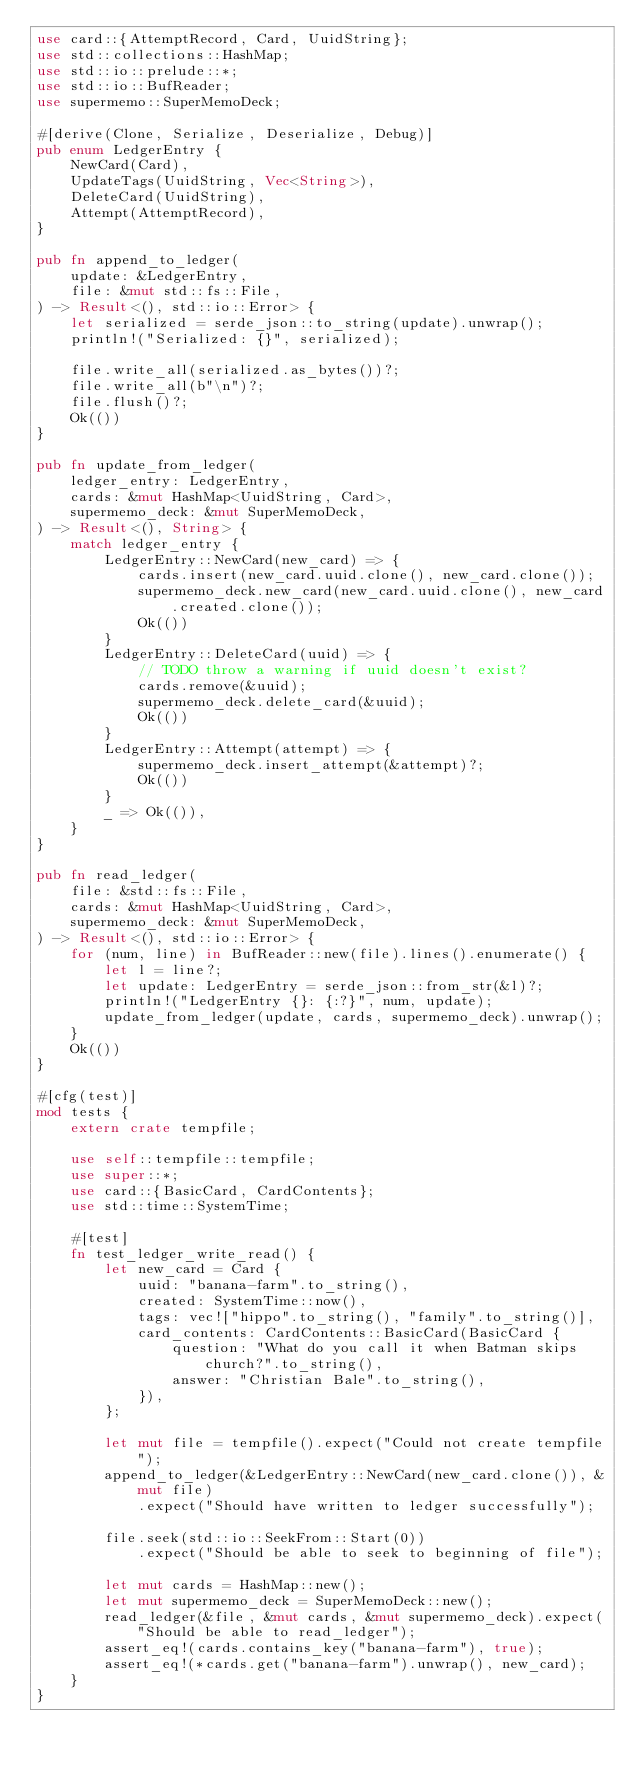<code> <loc_0><loc_0><loc_500><loc_500><_Rust_>use card::{AttemptRecord, Card, UuidString};
use std::collections::HashMap;
use std::io::prelude::*;
use std::io::BufReader;
use supermemo::SuperMemoDeck;

#[derive(Clone, Serialize, Deserialize, Debug)]
pub enum LedgerEntry {
    NewCard(Card),
    UpdateTags(UuidString, Vec<String>),
    DeleteCard(UuidString),
    Attempt(AttemptRecord),
}

pub fn append_to_ledger(
    update: &LedgerEntry,
    file: &mut std::fs::File,
) -> Result<(), std::io::Error> {
    let serialized = serde_json::to_string(update).unwrap();
    println!("Serialized: {}", serialized);

    file.write_all(serialized.as_bytes())?;
    file.write_all(b"\n")?;
    file.flush()?;
    Ok(())
}

pub fn update_from_ledger(
    ledger_entry: LedgerEntry,
    cards: &mut HashMap<UuidString, Card>,
    supermemo_deck: &mut SuperMemoDeck,
) -> Result<(), String> {
    match ledger_entry {
        LedgerEntry::NewCard(new_card) => {
            cards.insert(new_card.uuid.clone(), new_card.clone());
            supermemo_deck.new_card(new_card.uuid.clone(), new_card.created.clone());
            Ok(())
        }
        LedgerEntry::DeleteCard(uuid) => {
            // TODO throw a warning if uuid doesn't exist?
            cards.remove(&uuid);
            supermemo_deck.delete_card(&uuid);
            Ok(())
        }
        LedgerEntry::Attempt(attempt) => {
            supermemo_deck.insert_attempt(&attempt)?;
            Ok(())
        }
        _ => Ok(()),
    }
}

pub fn read_ledger(
    file: &std::fs::File,
    cards: &mut HashMap<UuidString, Card>,
    supermemo_deck: &mut SuperMemoDeck,
) -> Result<(), std::io::Error> {
    for (num, line) in BufReader::new(file).lines().enumerate() {
        let l = line?;
        let update: LedgerEntry = serde_json::from_str(&l)?;
        println!("LedgerEntry {}: {:?}", num, update);
        update_from_ledger(update, cards, supermemo_deck).unwrap();
    }
    Ok(())
}

#[cfg(test)]
mod tests {
    extern crate tempfile;

    use self::tempfile::tempfile;
    use super::*;
    use card::{BasicCard, CardContents};
    use std::time::SystemTime;

    #[test]
    fn test_ledger_write_read() {
        let new_card = Card {
            uuid: "banana-farm".to_string(),
            created: SystemTime::now(),
            tags: vec!["hippo".to_string(), "family".to_string()],
            card_contents: CardContents::BasicCard(BasicCard {
                question: "What do you call it when Batman skips church?".to_string(),
                answer: "Christian Bale".to_string(),
            }),
        };

        let mut file = tempfile().expect("Could not create tempfile");
        append_to_ledger(&LedgerEntry::NewCard(new_card.clone()), &mut file)
            .expect("Should have written to ledger successfully");

        file.seek(std::io::SeekFrom::Start(0))
            .expect("Should be able to seek to beginning of file");

        let mut cards = HashMap::new();
        let mut supermemo_deck = SuperMemoDeck::new();
        read_ledger(&file, &mut cards, &mut supermemo_deck).expect("Should be able to read_ledger");
        assert_eq!(cards.contains_key("banana-farm"), true);
        assert_eq!(*cards.get("banana-farm").unwrap(), new_card);
    }
}
</code> 